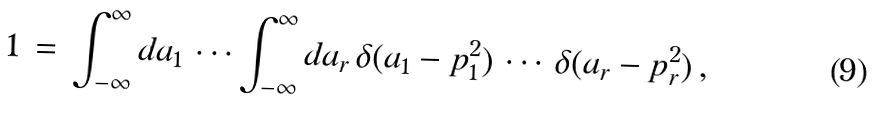Convert formula to latex. <formula><loc_0><loc_0><loc_500><loc_500>1 \, = \, \int _ { - \infty } ^ { \infty } d a _ { 1 } \, \cdots \int _ { - \infty } ^ { \infty } d a _ { r } \, \delta ( a _ { 1 } - p _ { 1 } ^ { 2 } ) \, \cdots \, \delta ( a _ { r } - p _ { r } ^ { 2 } ) \, ,</formula> 